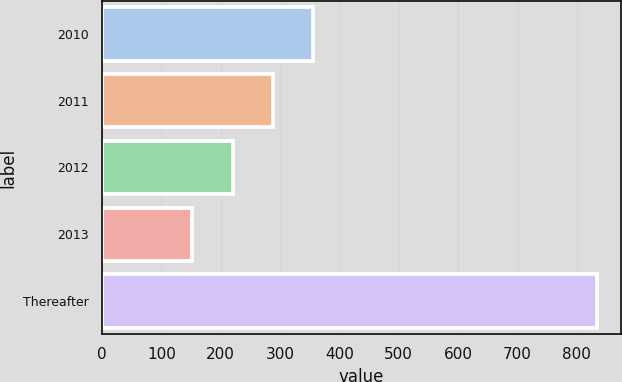Convert chart to OTSL. <chart><loc_0><loc_0><loc_500><loc_500><bar_chart><fcel>2010<fcel>2011<fcel>2012<fcel>2013<fcel>Thereafter<nl><fcel>356.3<fcel>288.2<fcel>220.1<fcel>152<fcel>833<nl></chart> 